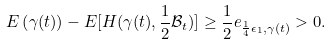<formula> <loc_0><loc_0><loc_500><loc_500>E \left ( \gamma ( t ) \right ) - E [ H ( \gamma ( t ) , \frac { 1 } { 2 } \mathcal { B } _ { t } ) ] \geq \frac { 1 } { 2 } e _ { \frac { 1 } { 4 } \epsilon _ { 1 } , \gamma ( t ) } > 0 .</formula> 